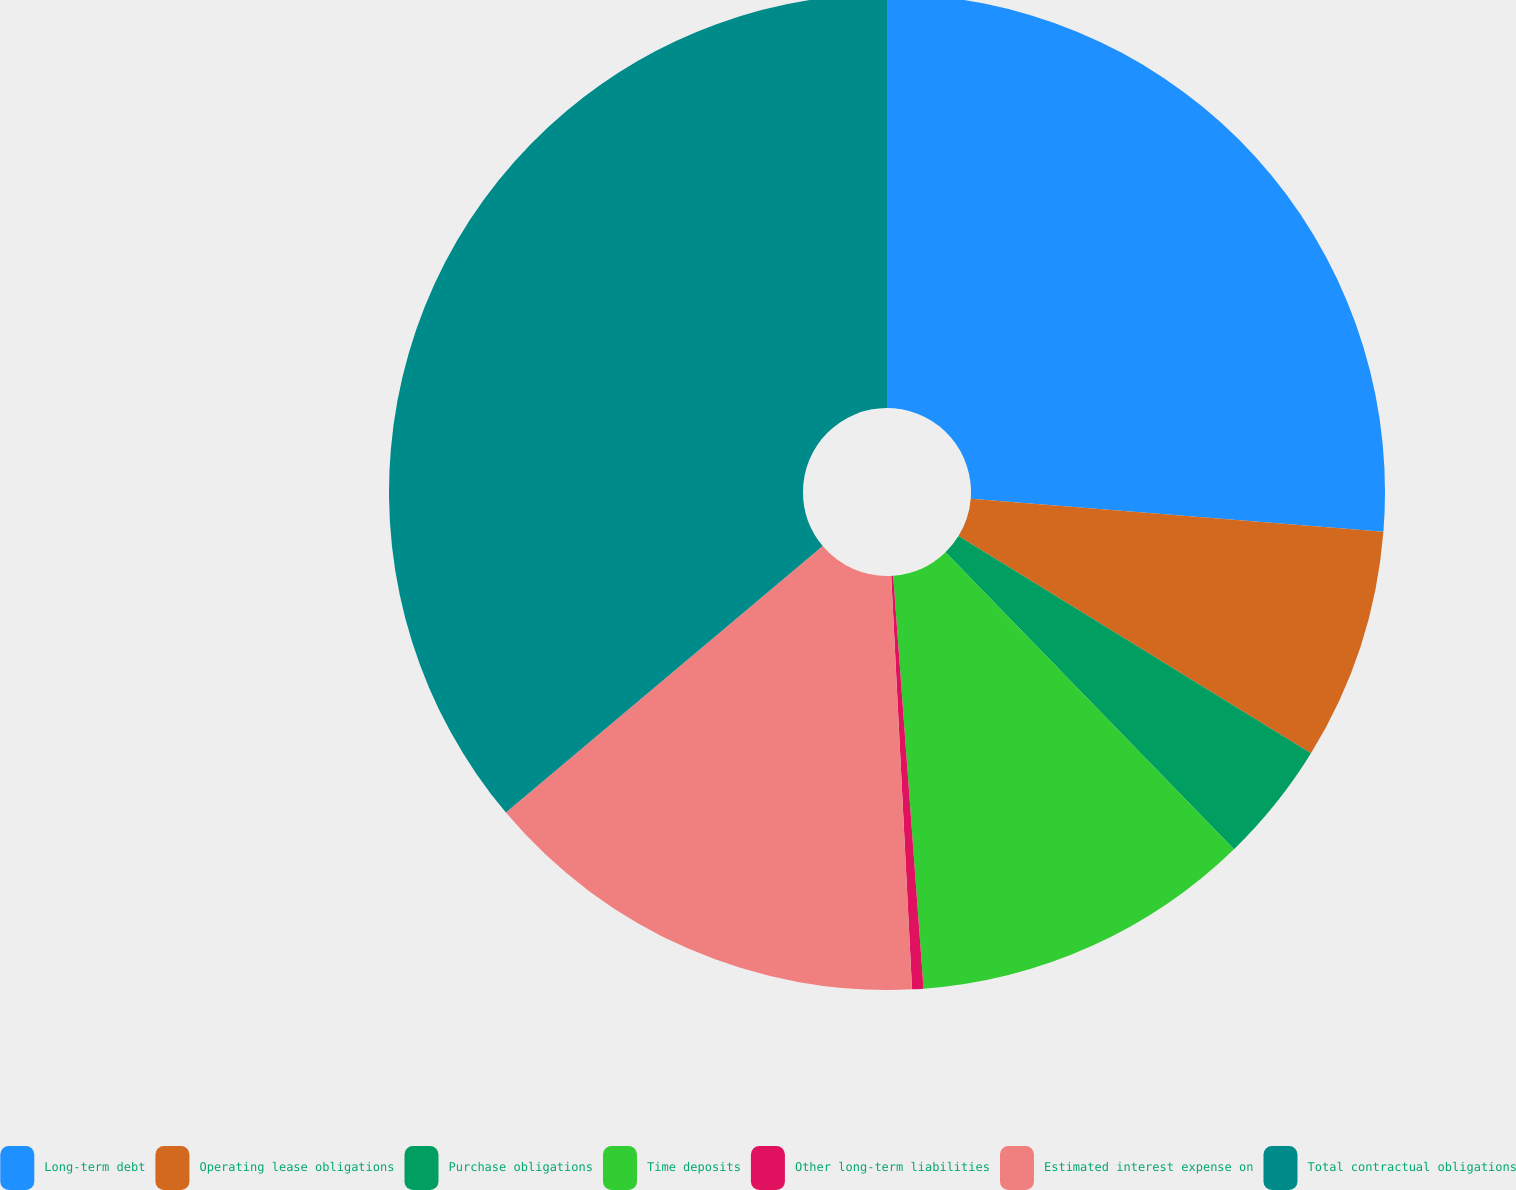Convert chart. <chart><loc_0><loc_0><loc_500><loc_500><pie_chart><fcel>Long-term debt<fcel>Operating lease obligations<fcel>Purchase obligations<fcel>Time deposits<fcel>Other long-term liabilities<fcel>Estimated interest expense on<fcel>Total contractual obligations<nl><fcel>26.27%<fcel>7.52%<fcel>3.94%<fcel>11.1%<fcel>0.37%<fcel>14.67%<fcel>36.13%<nl></chart> 